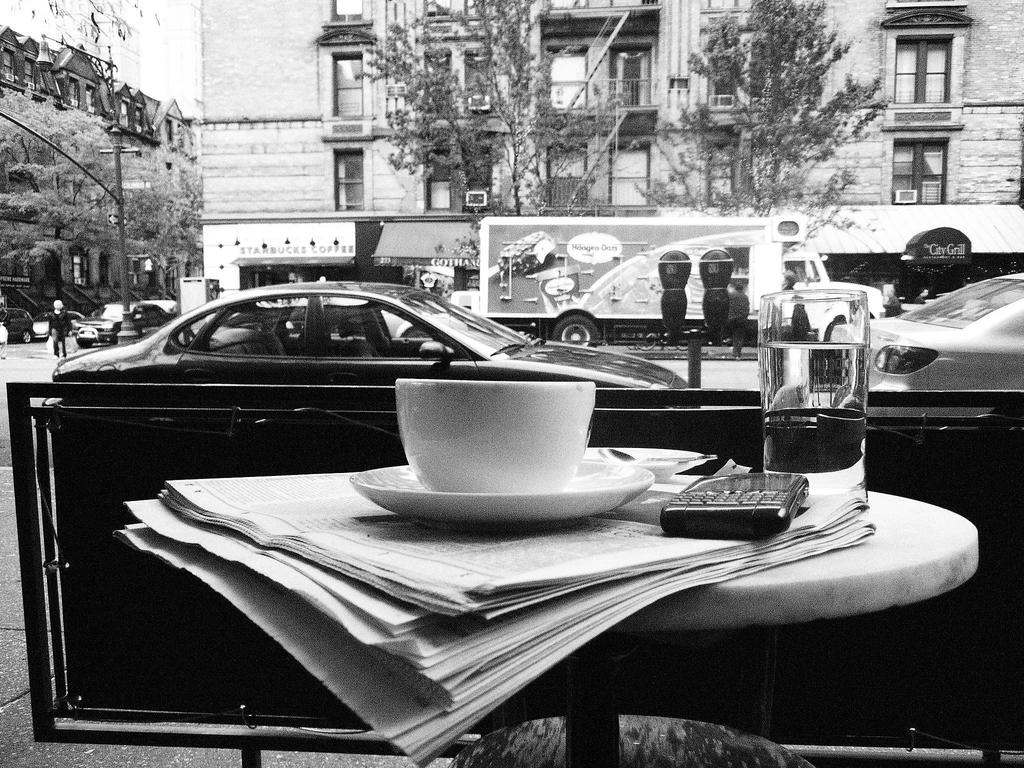What type of vehicle can be seen in the image? There is a car in the image. What type of structure is present in the image? There is a building in the image. What type of plant is visible in the image? There is a tree in the image. What part of the natural environment is visible in the image? The sky is visible in the image. What type of vertical structure is present in the image? There is a pole in the image. What type of appliance is present in the image? There is an air conditioner in the image. What type of vehicle, other than a car, is present in the image? There is a truck in the image. What type of furniture is present in the image? There is a table in the image. What type of object is present on the table in the image? There is a mobile on the table. What type of container is present on the table in the image? There is a glass on the table. What type of reading material is present on the table in the image? There is a newspaper on the table. What type of drinking vessel is present on the table in the image? There is a cup on the table. What type of plate-like object is present on the table in the image? There is a saucer on the table. Where is the veil located in the image? There is no veil present in the image. What type of box is visible in the image? There is no box present in the image. What type of distribution is occurring in the image? The image does not depict any distribution; it shows a car, a building, a tree, the sky, a pole, an air conditioner, a truck, a table, a mobile, a glass, a newspaper, a cup, and a saucer. 